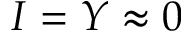Convert formula to latex. <formula><loc_0><loc_0><loc_500><loc_500>I = Y \approx 0</formula> 